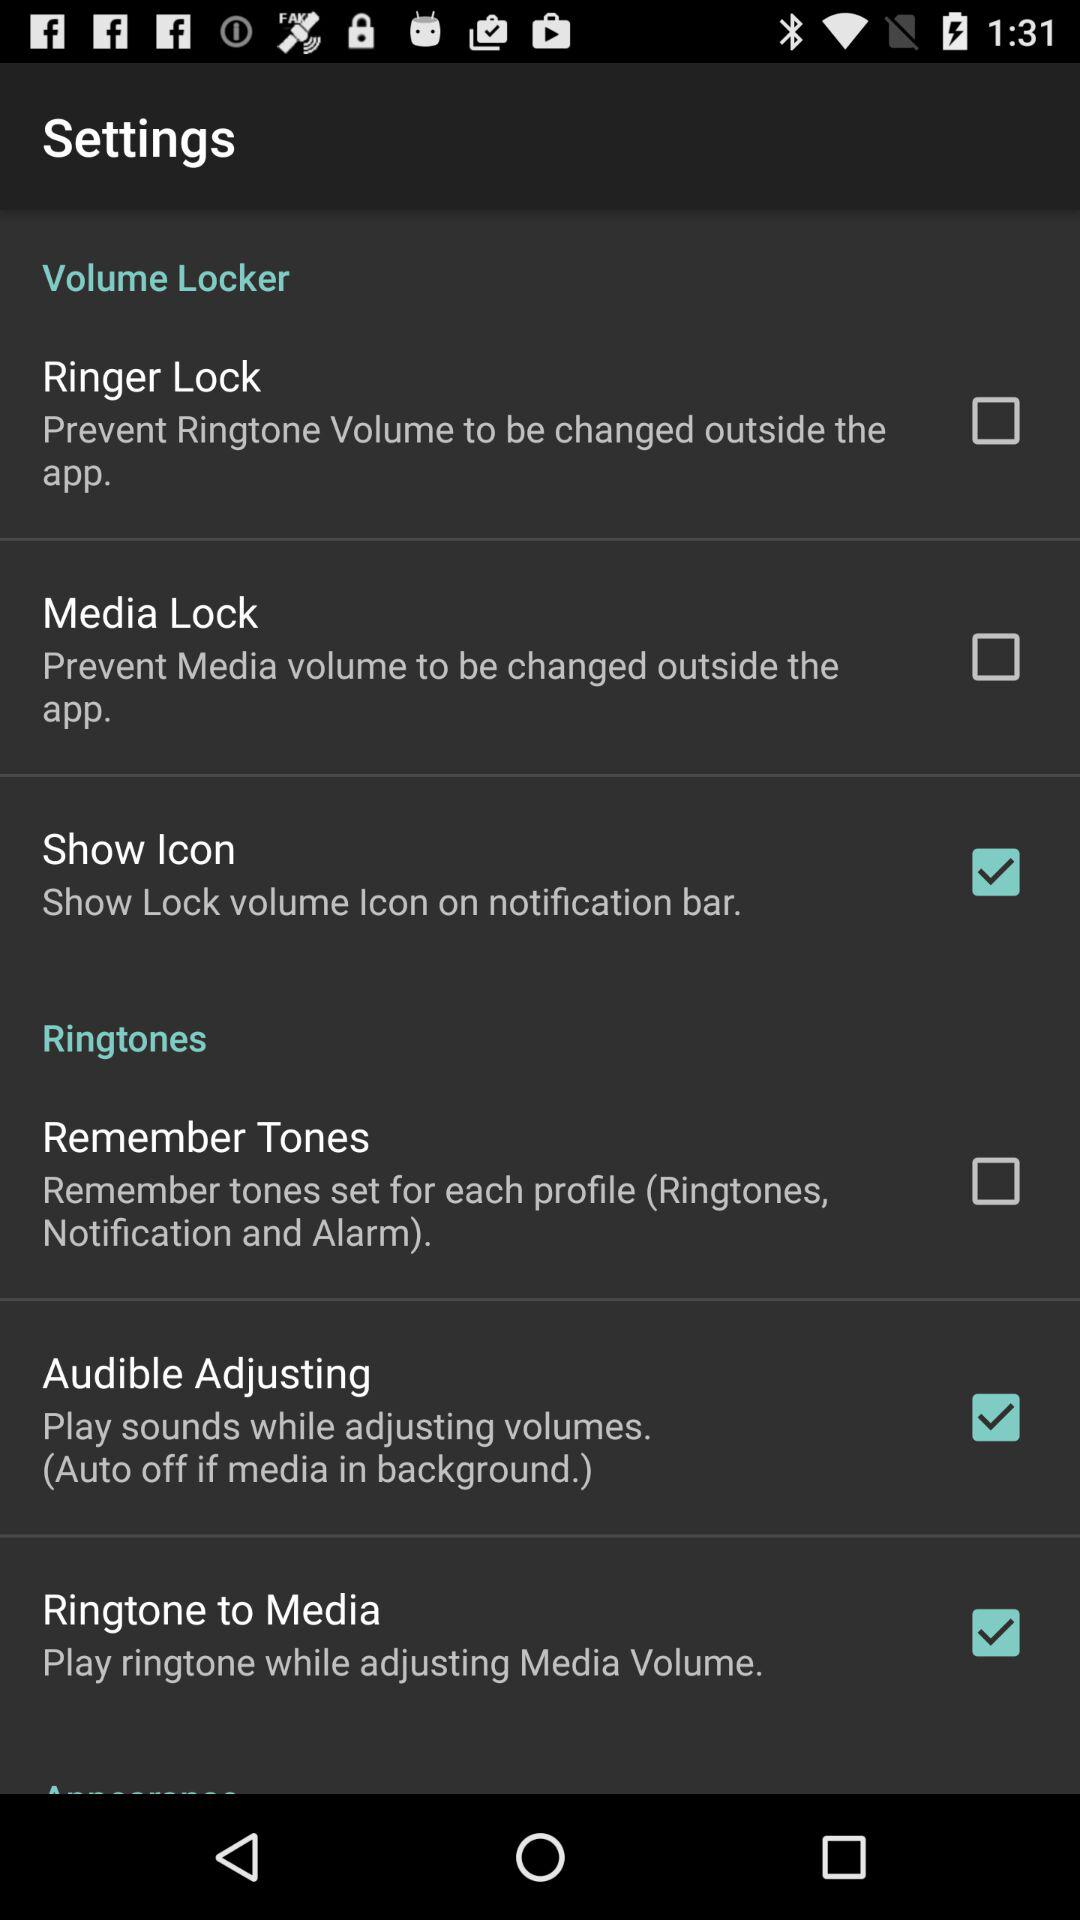What is the status of "Ringer Lock"? The status is "off". 